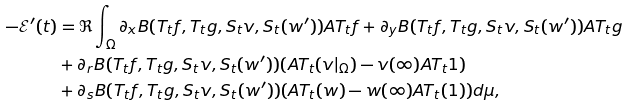<formula> <loc_0><loc_0><loc_500><loc_500>- \mathcal { E } ^ { \prime } ( t ) & = \Re \int _ { \Omega } \partial _ { x } B ( T _ { t } f , T _ { t } g , S _ { t } v , S _ { t } ( w ^ { \prime } ) ) A T _ { t } f + \partial _ { y } B ( T _ { t } f , T _ { t } g , S _ { t } v , S _ { t } ( w ^ { \prime } ) ) A T _ { t } g \\ & + \partial _ { r } B ( T _ { t } f , T _ { t } g , S _ { t } v , S _ { t } ( w ^ { \prime } ) ) ( A T _ { t } ( v | _ { \Omega } ) - v ( \infty ) A T _ { t } 1 ) \\ & + \partial _ { s } B ( T _ { t } f , T _ { t } g , S _ { t } v , S _ { t } ( w ^ { \prime } ) ) ( A T _ { t } ( w ) - w ( \infty ) A T _ { t } ( 1 ) ) d \mu ,</formula> 